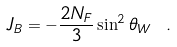<formula> <loc_0><loc_0><loc_500><loc_500>J _ { B } = - { \frac { 2 N _ { F } } { 3 } } \sin ^ { 2 } \theta _ { W } \ .</formula> 